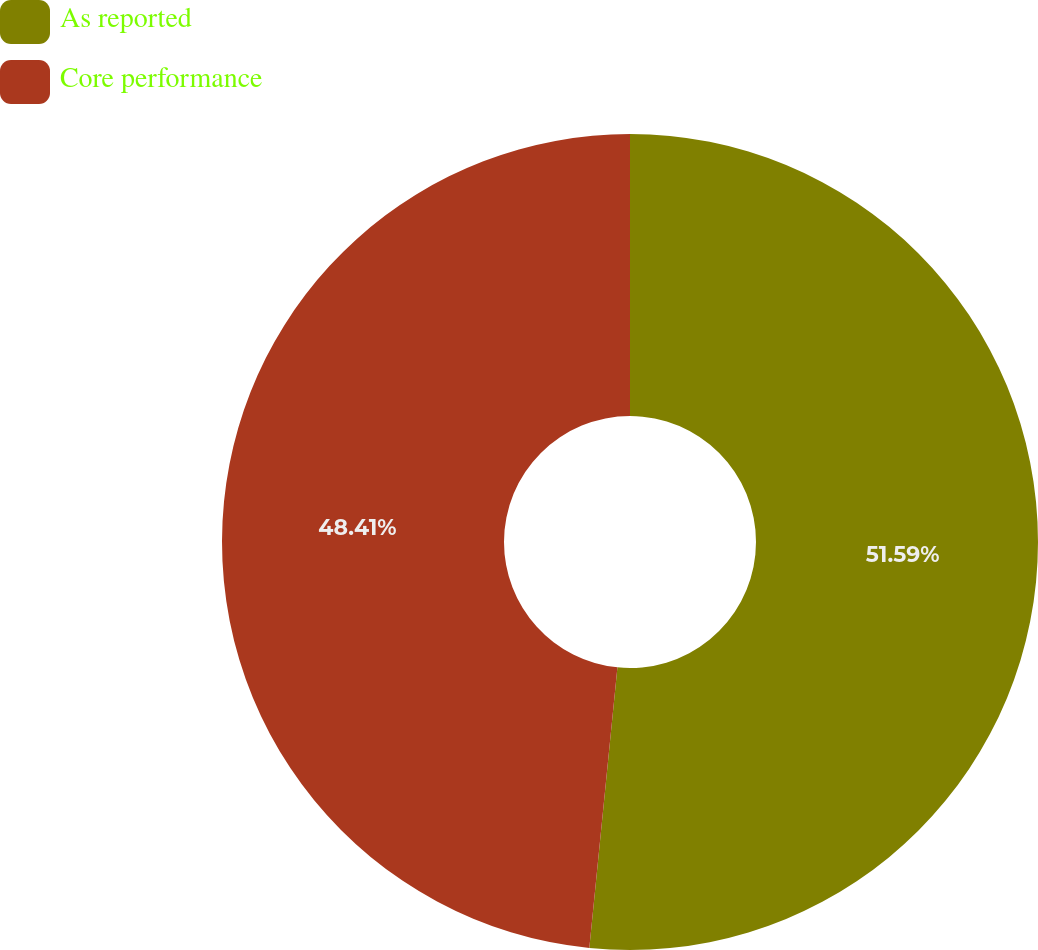Convert chart. <chart><loc_0><loc_0><loc_500><loc_500><pie_chart><fcel>As reported<fcel>Core performance<nl><fcel>51.59%<fcel>48.41%<nl></chart> 